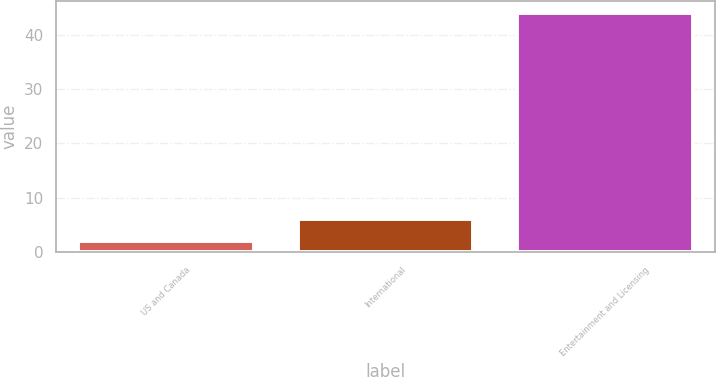Convert chart. <chart><loc_0><loc_0><loc_500><loc_500><bar_chart><fcel>US and Canada<fcel>International<fcel>Entertainment and Licensing<nl><fcel>2<fcel>6.2<fcel>44<nl></chart> 